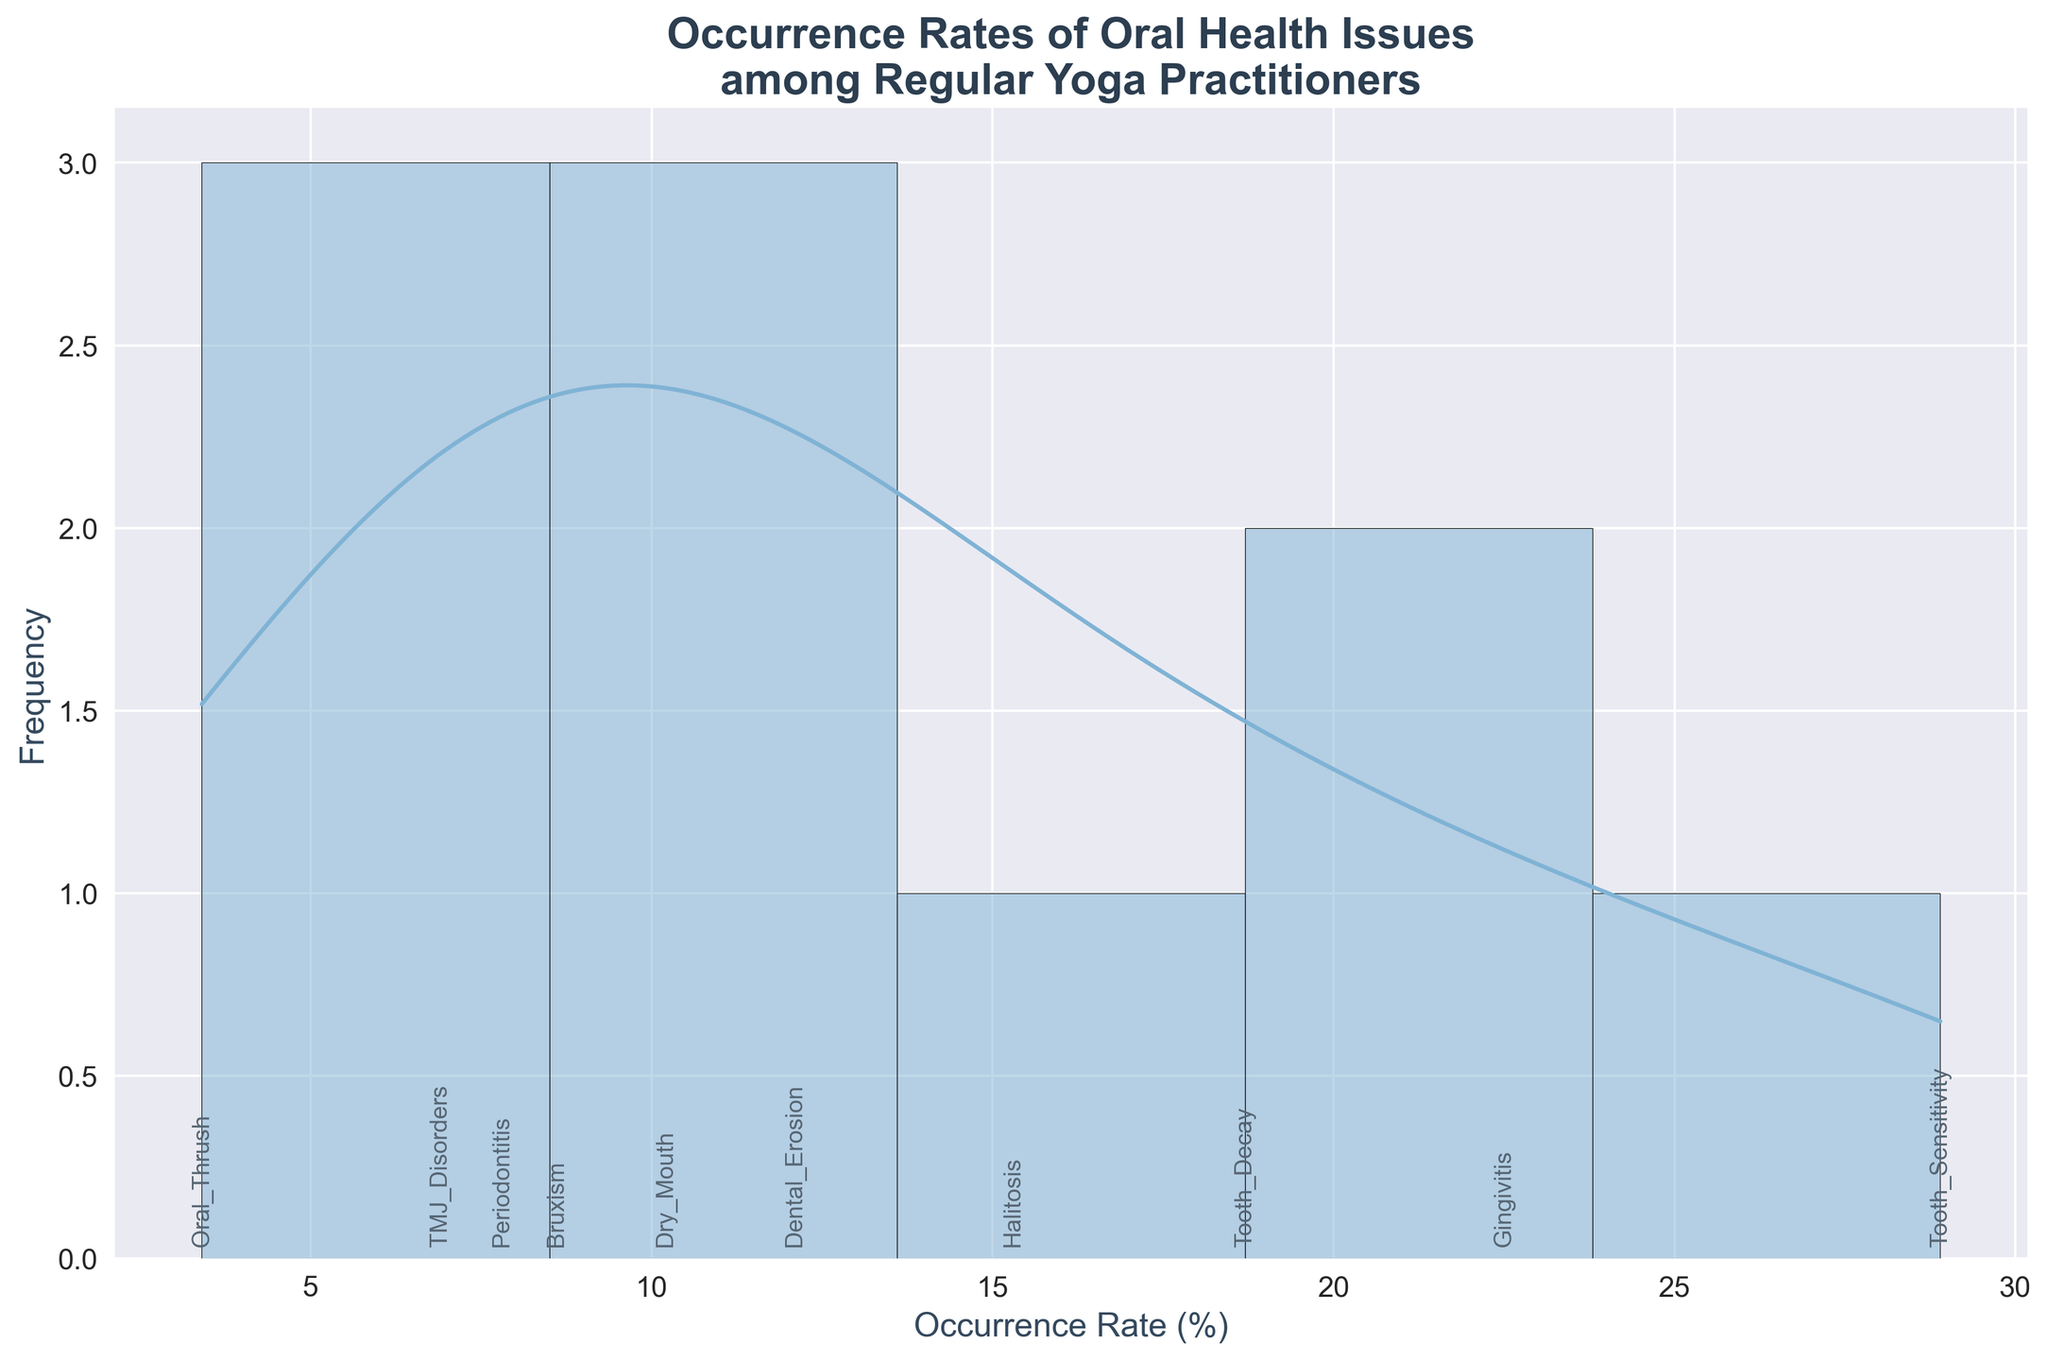What's the title of the figure? The title of the figure is displayed at the top of the plot. It helps in understanding what the plot represents.
Answer: Occurrence Rates of Oral Health Issues among Regular Yoga Practitioners How many oral health issues are shown in the figure? Count the number of distinct labels or annotations on the x-axis which represent oral health issues.
Answer: 10 Which oral health issue has the highest occurrence rate? Look for the tallest bar or the highest peak in the KDE curve and then read the corresponding label.
Answer: Tooth Sensitivity What is the occurrence rate of Halitosis? Find the label 'Halitosis' on the x-axis and check the corresponding x-coordinate value.
Answer: 15.3% Are there more issues with an occurrence rate above 20% or below 10%? Count the number of issues with occurrence rates above 20% and those below 10%. Compare the counts.
Answer: Below 10% What is the average occurrence rate of Gingivitis and Tooth Decay? Sum the occurrence rates of Gingivitis (22.5) and Tooth Decay (18.7), then divide by 2 to find the average.
Answer: 20.6% What is the median occurrence rate among the listed issues? List all occurrence rates in ascending order and find the middle value.
Answer: 12.1% Which has a higher occurrence rate: Periodontitis or Dry Mouth? Compare the height of the bars or the values next to 'Periodontitis' and 'Dry Mouth'.
Answer: Dry Mouth What's the difference in occurrence rate between Dental Erosion and Oral Thrush? Subtract the occurrence rate of Oral Thrush (3.4) from that of Dental Erosion (12.1).
Answer: 8.7% Which oral health issues have an occurrence rate less than 10%? Identify the issues with bars ending below the 10% mark or on the left of the 10% point on the x-axis.
Answer: Bruxism, Periodontitis, Oral Thrush, TMJ Disorders 